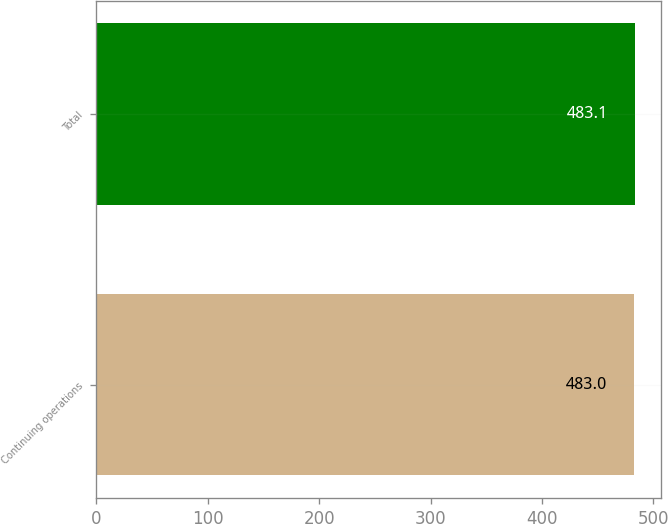<chart> <loc_0><loc_0><loc_500><loc_500><bar_chart><fcel>Continuing operations<fcel>Total<nl><fcel>483<fcel>483.1<nl></chart> 